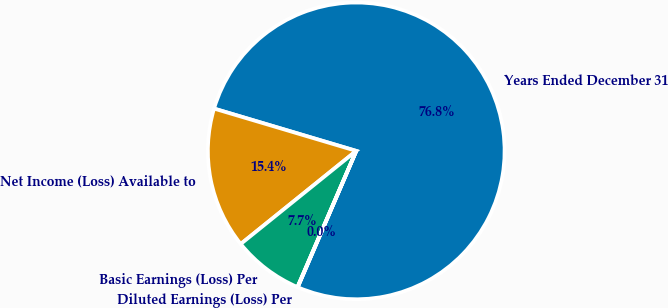<chart> <loc_0><loc_0><loc_500><loc_500><pie_chart><fcel>Years Ended December 31<fcel>Net Income (Loss) Available to<fcel>Basic Earnings (Loss) Per<fcel>Diluted Earnings (Loss) Per<nl><fcel>76.85%<fcel>15.4%<fcel>7.72%<fcel>0.03%<nl></chart> 